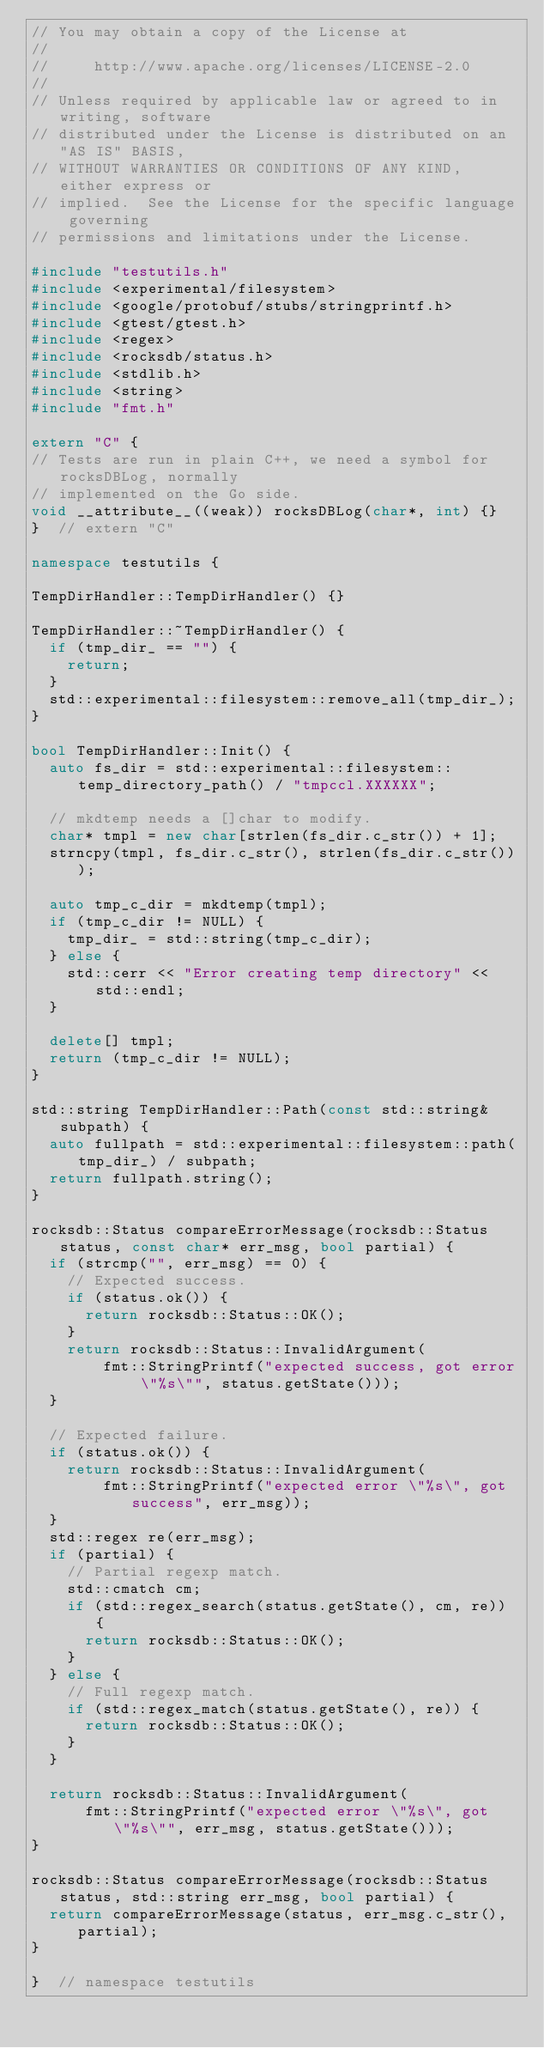Convert code to text. <code><loc_0><loc_0><loc_500><loc_500><_C++_>// You may obtain a copy of the License at
//
//     http://www.apache.org/licenses/LICENSE-2.0
//
// Unless required by applicable law or agreed to in writing, software
// distributed under the License is distributed on an "AS IS" BASIS,
// WITHOUT WARRANTIES OR CONDITIONS OF ANY KIND, either express or
// implied.  See the License for the specific language governing
// permissions and limitations under the License.

#include "testutils.h"
#include <experimental/filesystem>
#include <google/protobuf/stubs/stringprintf.h>
#include <gtest/gtest.h>
#include <regex>
#include <rocksdb/status.h>
#include <stdlib.h>
#include <string>
#include "fmt.h"

extern "C" {
// Tests are run in plain C++, we need a symbol for rocksDBLog, normally
// implemented on the Go side.
void __attribute__((weak)) rocksDBLog(char*, int) {}
}  // extern "C"

namespace testutils {

TempDirHandler::TempDirHandler() {}

TempDirHandler::~TempDirHandler() {
  if (tmp_dir_ == "") {
    return;
  }
  std::experimental::filesystem::remove_all(tmp_dir_);
}

bool TempDirHandler::Init() {
  auto fs_dir = std::experimental::filesystem::temp_directory_path() / "tmpccl.XXXXXX";

  // mkdtemp needs a []char to modify.
  char* tmpl = new char[strlen(fs_dir.c_str()) + 1];
  strncpy(tmpl, fs_dir.c_str(), strlen(fs_dir.c_str()));

  auto tmp_c_dir = mkdtemp(tmpl);
  if (tmp_c_dir != NULL) {
    tmp_dir_ = std::string(tmp_c_dir);
  } else {
    std::cerr << "Error creating temp directory" << std::endl;
  }

  delete[] tmpl;
  return (tmp_c_dir != NULL);
}

std::string TempDirHandler::Path(const std::string& subpath) {
  auto fullpath = std::experimental::filesystem::path(tmp_dir_) / subpath;
  return fullpath.string();
}

rocksdb::Status compareErrorMessage(rocksdb::Status status, const char* err_msg, bool partial) {
  if (strcmp("", err_msg) == 0) {
    // Expected success.
    if (status.ok()) {
      return rocksdb::Status::OK();
    }
    return rocksdb::Status::InvalidArgument(
        fmt::StringPrintf("expected success, got error \"%s\"", status.getState()));
  }

  // Expected failure.
  if (status.ok()) {
    return rocksdb::Status::InvalidArgument(
        fmt::StringPrintf("expected error \"%s\", got success", err_msg));
  }
  std::regex re(err_msg);
  if (partial) {
    // Partial regexp match.
    std::cmatch cm;
    if (std::regex_search(status.getState(), cm, re)) {
      return rocksdb::Status::OK();
    }
  } else {
    // Full regexp match.
    if (std::regex_match(status.getState(), re)) {
      return rocksdb::Status::OK();
    }
  }

  return rocksdb::Status::InvalidArgument(
      fmt::StringPrintf("expected error \"%s\", got \"%s\"", err_msg, status.getState()));
}

rocksdb::Status compareErrorMessage(rocksdb::Status status, std::string err_msg, bool partial) {
  return compareErrorMessage(status, err_msg.c_str(), partial);
}

}  // namespace testutils
</code> 